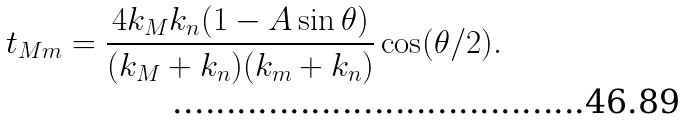Convert formula to latex. <formula><loc_0><loc_0><loc_500><loc_500>t _ { M m } = \frac { 4 k _ { M } k _ { n } ( 1 - A \sin \theta ) } { ( k _ { M } + k _ { n } ) ( k _ { m } + k _ { n } ) } \cos ( \theta / 2 ) .</formula> 